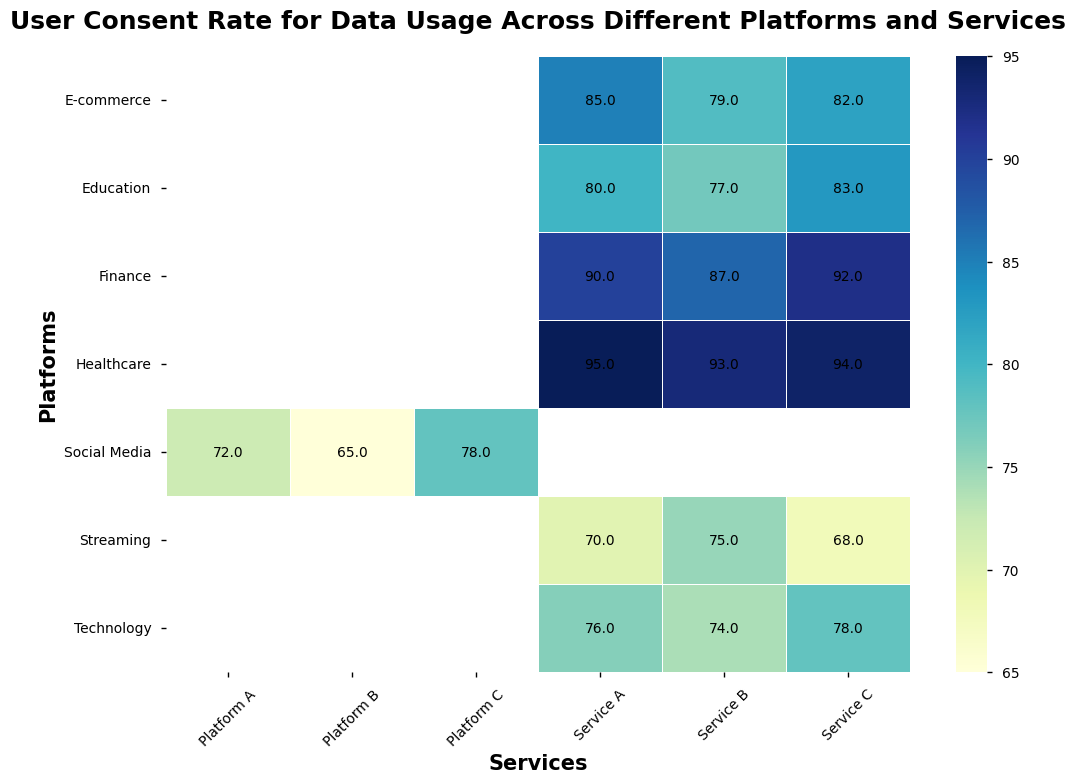Which platform-service combination has the highest consent rate? By examining the heatmap, the darkest portion indicates the highest consent rate. In the Finance platform with Service C, the consent rate is the darkest, corresponding to 92%.
Answer: Finance-Service C Which platform shows the lowest overall consent rate and what's the value? By observing all the platforms, the Streaming platform consistently shows lighter colors, indicating lower consent rates. Checking the numerical values confirms that Streaming Service C has the lowest consent rate of 68%.
Answer: Streaming, 68% What's the average consent rate across all services in the E-commerce platform? E-commerce consent rates are Service A: 85%, Service B: 79%, Service C: 82%. The average is calculated as (85 + 79 + 82) / 3 = 82%.
Answer: 82% Is the consent rate for Technology Service B higher or lower than the average consent rate for E-commerce services? The consent rate for Technology Service B is 74%. As calculated earlier, the average consent rate for E-commerce is 82%. Comparing the two, 74% < 82%.
Answer: Lower What is the difference between the highest and the lowest consent rate in the Healthcare platform? In Healthcare, the consent rates are Service A: 95%, Service B: 93%, Service C: 94%. The difference between the highest (95%) and the lowest (93%) is 95 - 93 = 2%.
Answer: 2% Which platform has the smallest range of consent rates? The range is calculated as the difference between the highest and lowest consent rates in each platform. 
Social Media: 78 - 65 = 13
E-commerce: 85 - 79 = 6
Streaming: 75 - 68 = 7
Finance: 92 - 87 = 5
Healthcare: 95 - 93 = 2
Education: 83 - 77 = 6
Technology: 78 - 74 = 4
The platform with the smallest range is Healthcare, with a range of 2%.
Answer: Healthcare Compare the consent rate for Education Service A to the consent rate for Technology Service A and state which is higher. The consent rate for Education Service A is 80%, while for Technology Service A, it is 76%. Comparing the two, 80% > 76%.
Answer: Education Service A What’s the median consent rate for the Social Media platform? The consent rates for Social Media are 72%, 65%, and 78%. Ordering them as 65%, 72%, 78%, the median value is the middle value, which is 72%.
Answer: 72% Identify the platform with the highest variance in consent rates and explain your reasoning. Variance measures the spread of the consent rate values. Calculating the variance for all platforms:
Social Media: Variance = ((72-71.67)^2 + (65-71.67)^2 + (78-71.67)^2)/3 = 28.22 (approx)
E-commerce: Variance = ((85-82)^2 + (79-82)^2 + (82-82)^2)/3 = 9.33 (approx)
Streaming: Variance = ((70-71)^2 + (75-71)^2 + (68-71)^2)/3 = 14.67 (approx)
Finance: Variance = ((90-89.67)^2 + (87-89.67)^2 + (92-89.67)^2)/3 = 7.56 (approx)
Healthcare: Variance = ((95-94)^2 + (93-94)^2 + (94-94)^2)/3 = 1 (approx)
Education: Variance = ((80-80)^2 + (77-80)^2 + (83-80)^2)/3 = 9.33 (approx)
Technology: Variance = ((76-76)^2 + (74-76)^2 + (78-76)^2)/3 = 4 (approx)
Social Media has the highest variance at approximately 28.22.
Answer: Social Media 